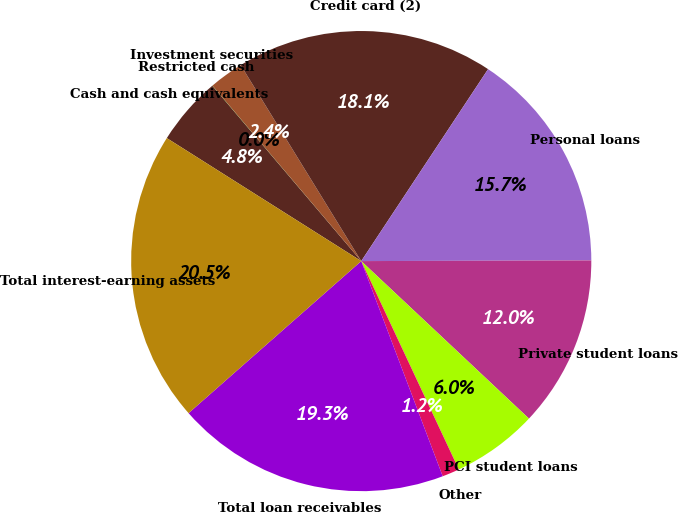Convert chart. <chart><loc_0><loc_0><loc_500><loc_500><pie_chart><fcel>Cash and cash equivalents<fcel>Restricted cash<fcel>Investment securities<fcel>Credit card (2)<fcel>Personal loans<fcel>Private student loans<fcel>PCI student loans<fcel>Other<fcel>Total loan receivables<fcel>Total interest-earning assets<nl><fcel>4.82%<fcel>0.01%<fcel>2.42%<fcel>18.07%<fcel>15.66%<fcel>12.05%<fcel>6.03%<fcel>1.21%<fcel>19.27%<fcel>20.47%<nl></chart> 